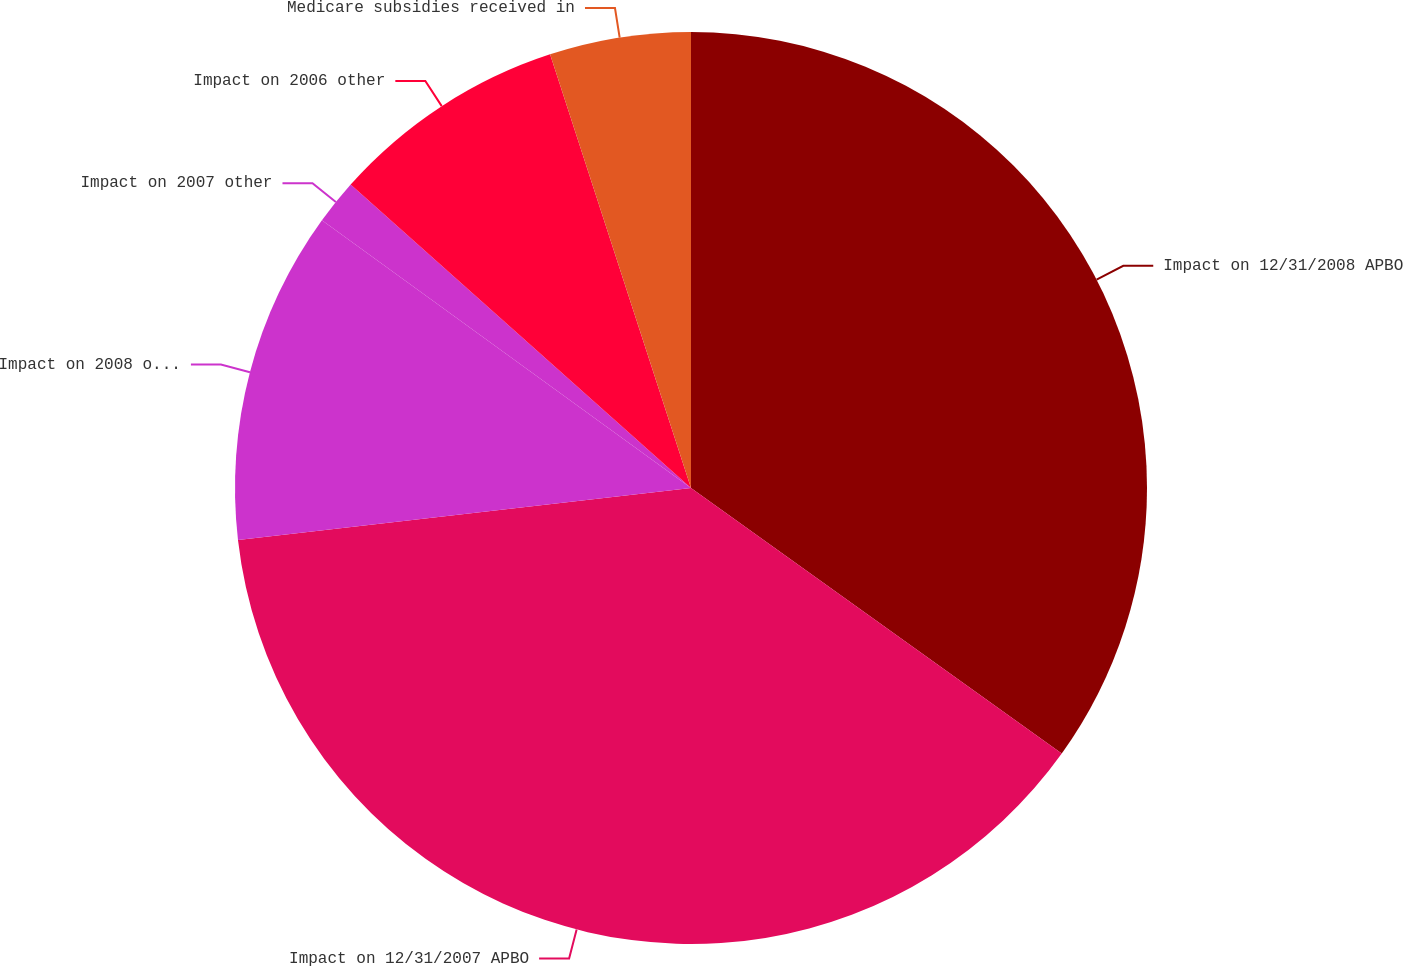Convert chart to OTSL. <chart><loc_0><loc_0><loc_500><loc_500><pie_chart><fcel>Impact on 12/31/2008 APBO<fcel>Impact on 12/31/2007 APBO<fcel>Impact on 2008 other<fcel>Impact on 2007 other<fcel>Impact on 2006 other<fcel>Medicare subsidies received in<nl><fcel>34.89%<fcel>38.29%<fcel>11.81%<fcel>1.6%<fcel>8.41%<fcel>5.0%<nl></chart> 